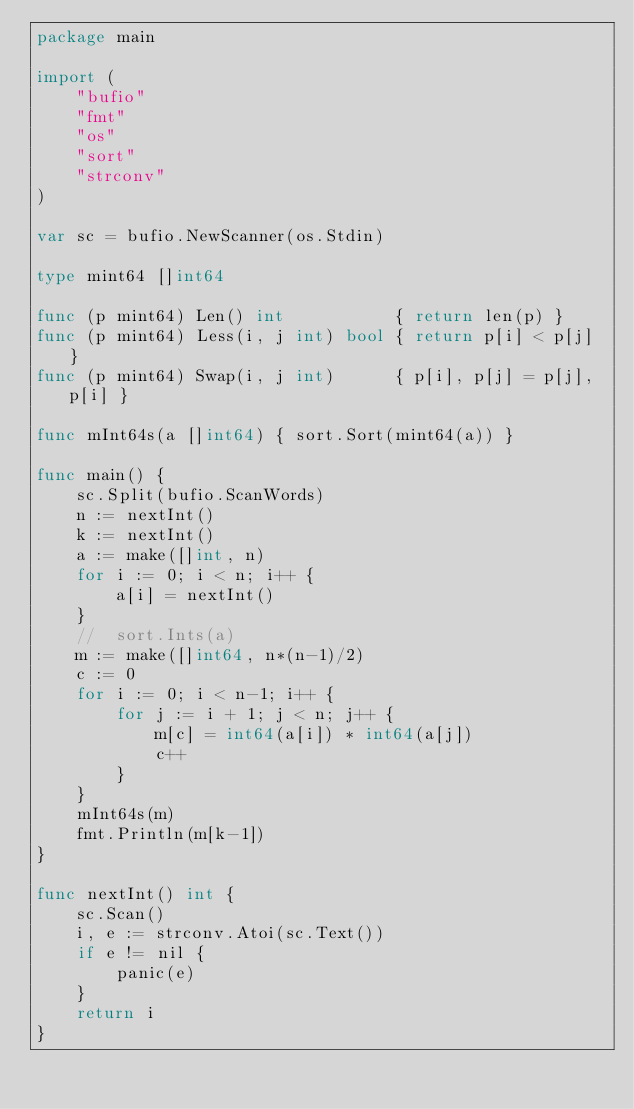Convert code to text. <code><loc_0><loc_0><loc_500><loc_500><_Go_>package main

import (
	"bufio"
	"fmt"
	"os"
	"sort"
	"strconv"
)

var sc = bufio.NewScanner(os.Stdin)

type mint64 []int64

func (p mint64) Len() int           { return len(p) }
func (p mint64) Less(i, j int) bool { return p[i] < p[j] }
func (p mint64) Swap(i, j int)      { p[i], p[j] = p[j], p[i] }

func mInt64s(a []int64) { sort.Sort(mint64(a)) }

func main() {
	sc.Split(bufio.ScanWords)
	n := nextInt()
	k := nextInt()
	a := make([]int, n)
	for i := 0; i < n; i++ {
		a[i] = nextInt()
	}
	//	sort.Ints(a)
	m := make([]int64, n*(n-1)/2)
	c := 0
	for i := 0; i < n-1; i++ {
		for j := i + 1; j < n; j++ {
			m[c] = int64(a[i]) * int64(a[j])
			c++
		}
	}
	mInt64s(m)
	fmt.Println(m[k-1])
}

func nextInt() int {
	sc.Scan()
	i, e := strconv.Atoi(sc.Text())
	if e != nil {
		panic(e)
	}
	return i
}
</code> 